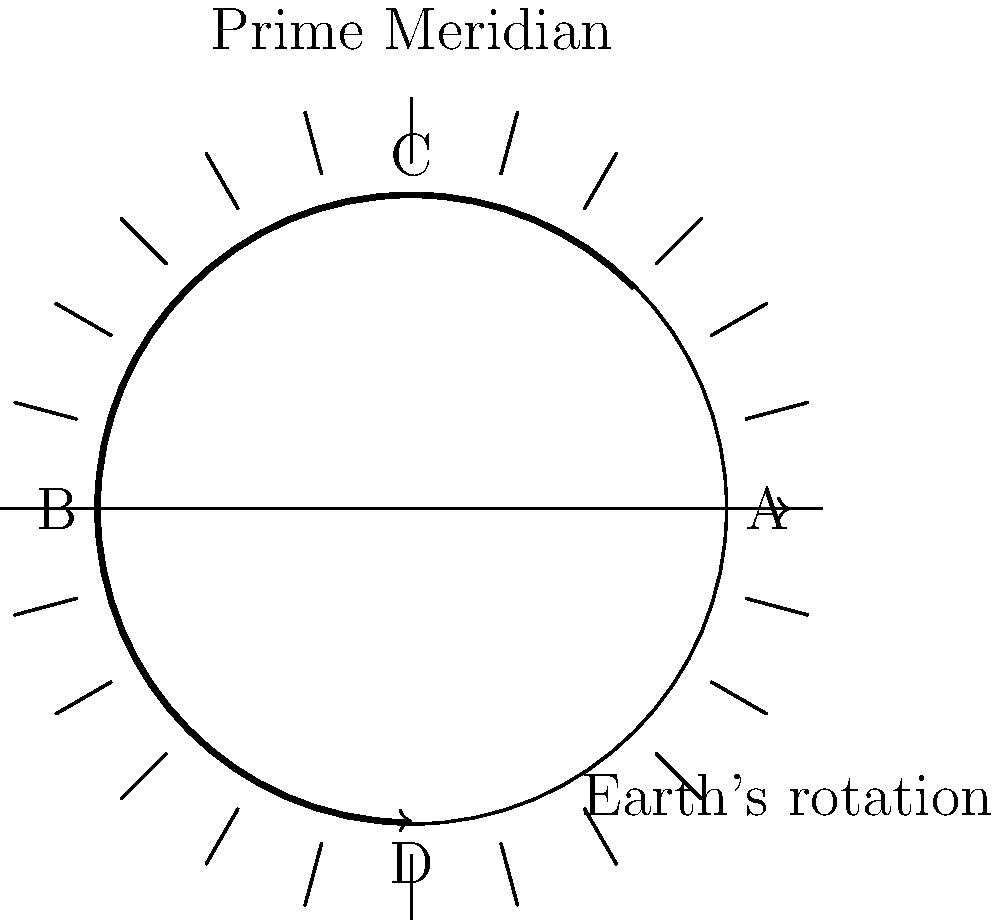As Earth rotates on its axis, different regions experience day and night at different times. If it's noon at point A (0° longitude), and Earth rotates 15° every hour, how many hours will it take for point B (180° longitude) to experience noon? Explain how this relates to the concept of time zones and global citizenship. To solve this problem, we need to follow these steps:

1. Understand Earth's rotation:
   - Earth rotates 360° in 24 hours
   - This means it rotates 15° per hour (360° ÷ 24 hours = 15°/hour)

2. Calculate the angle between points A and B:
   - Point A is at 0° longitude (Prime Meridian)
   - Point B is at 180° longitude
   - The angle between them is 180°

3. Calculate the time difference:
   - Time = Angle ÷ Rotation rate
   - Time = 180° ÷ (15°/hour) = 12 hours

4. Relate to time zones and global citizenship:
   - The Earth is divided into 24 time zones, each roughly 15° wide
   - This system allows for coordinated timekeeping across the globe
   - Understanding time zones is crucial for global communication and cooperation
   - As global citizens, students should be aware of how Earth's rotation affects daily life in different parts of the world
   - This knowledge promotes cultural understanding and facilitates international collaboration

The concept of time zones demonstrates how a natural phenomenon (Earth's rotation) influences human society and organization on a global scale. As educators, we can use this example to encourage students to think about other ways in which natural processes impact our interconnected world and how understanding these processes can foster global citizenship.
Answer: 12 hours 